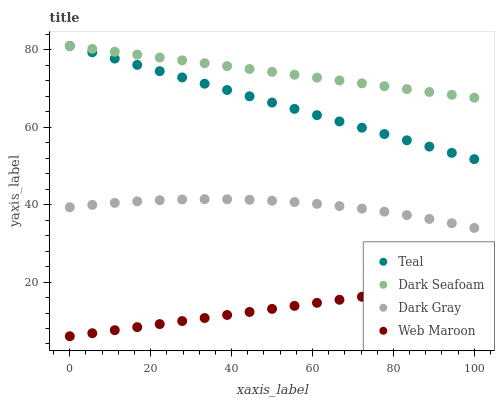Does Web Maroon have the minimum area under the curve?
Answer yes or no. Yes. Does Dark Seafoam have the maximum area under the curve?
Answer yes or no. Yes. Does Dark Seafoam have the minimum area under the curve?
Answer yes or no. No. Does Web Maroon have the maximum area under the curve?
Answer yes or no. No. Is Web Maroon the smoothest?
Answer yes or no. Yes. Is Dark Gray the roughest?
Answer yes or no. Yes. Is Dark Seafoam the smoothest?
Answer yes or no. No. Is Dark Seafoam the roughest?
Answer yes or no. No. Does Web Maroon have the lowest value?
Answer yes or no. Yes. Does Dark Seafoam have the lowest value?
Answer yes or no. No. Does Teal have the highest value?
Answer yes or no. Yes. Does Web Maroon have the highest value?
Answer yes or no. No. Is Web Maroon less than Teal?
Answer yes or no. Yes. Is Dark Seafoam greater than Web Maroon?
Answer yes or no. Yes. Does Teal intersect Dark Seafoam?
Answer yes or no. Yes. Is Teal less than Dark Seafoam?
Answer yes or no. No. Is Teal greater than Dark Seafoam?
Answer yes or no. No. Does Web Maroon intersect Teal?
Answer yes or no. No. 